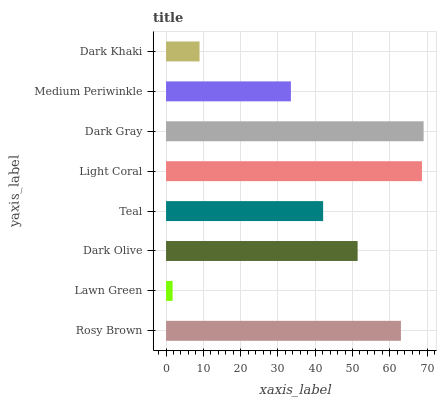Is Lawn Green the minimum?
Answer yes or no. Yes. Is Dark Gray the maximum?
Answer yes or no. Yes. Is Dark Olive the minimum?
Answer yes or no. No. Is Dark Olive the maximum?
Answer yes or no. No. Is Dark Olive greater than Lawn Green?
Answer yes or no. Yes. Is Lawn Green less than Dark Olive?
Answer yes or no. Yes. Is Lawn Green greater than Dark Olive?
Answer yes or no. No. Is Dark Olive less than Lawn Green?
Answer yes or no. No. Is Dark Olive the high median?
Answer yes or no. Yes. Is Teal the low median?
Answer yes or no. Yes. Is Dark Khaki the high median?
Answer yes or no. No. Is Medium Periwinkle the low median?
Answer yes or no. No. 